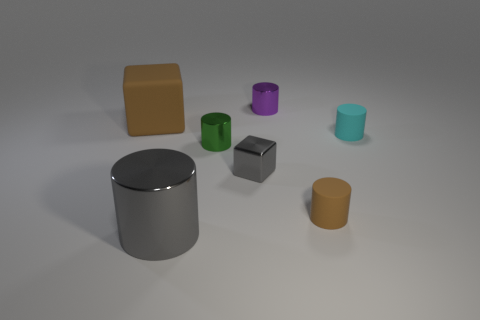The thing that is left of the large metal object is what color?
Keep it short and to the point. Brown. Are there any green things that have the same shape as the small cyan matte thing?
Make the answer very short. Yes. What is the material of the tiny gray object?
Your response must be concise. Metal. What size is the shiny cylinder that is on the right side of the large gray metal cylinder and in front of the cyan cylinder?
Offer a terse response. Small. What is the material of the block that is the same color as the large metallic cylinder?
Provide a succinct answer. Metal. How many big blue metallic cubes are there?
Ensure brevity in your answer.  0. Is the number of tiny yellow rubber things less than the number of small brown rubber cylinders?
Provide a succinct answer. Yes. What is the material of the purple cylinder that is the same size as the brown cylinder?
Keep it short and to the point. Metal. What number of objects are either blue things or tiny purple things?
Make the answer very short. 1. What number of tiny things are left of the cyan rubber cylinder and behind the small brown thing?
Your answer should be compact. 3. 